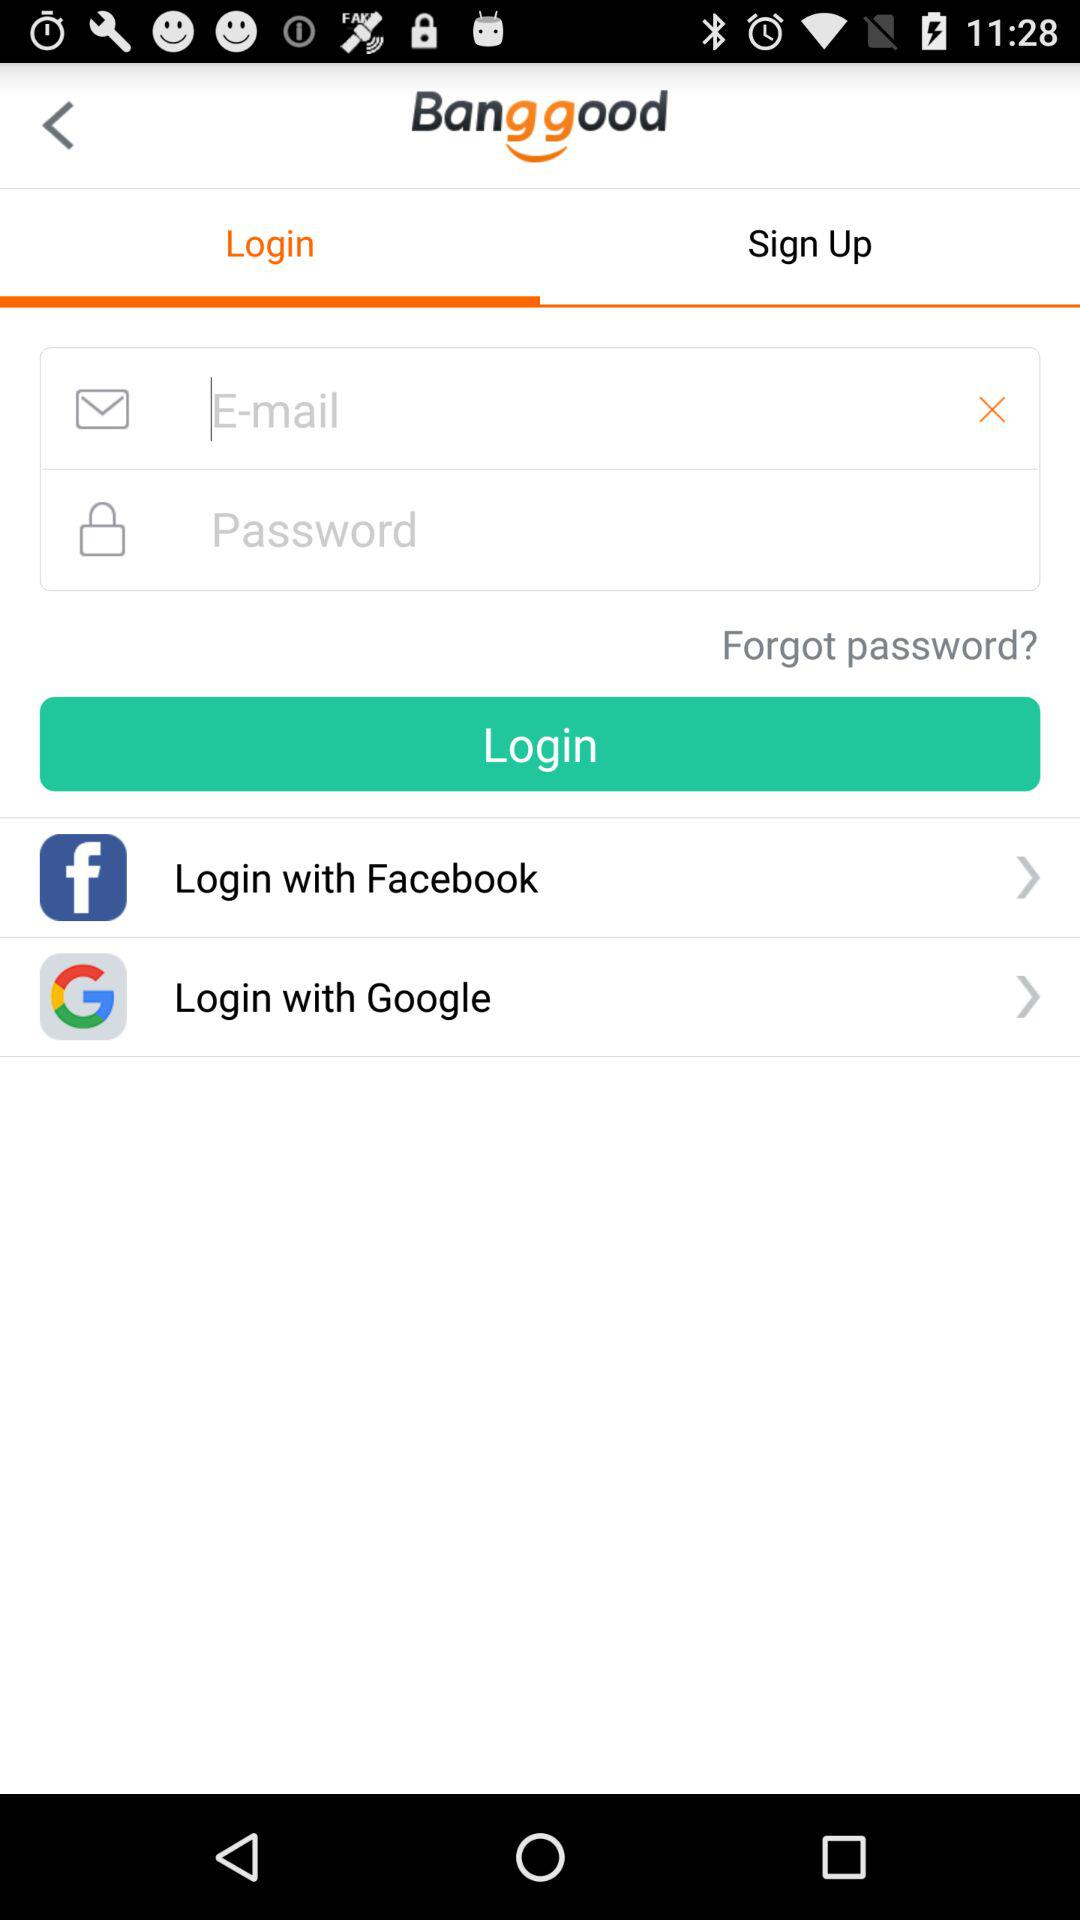Which tab is selected? The tab "Login" is selected. 